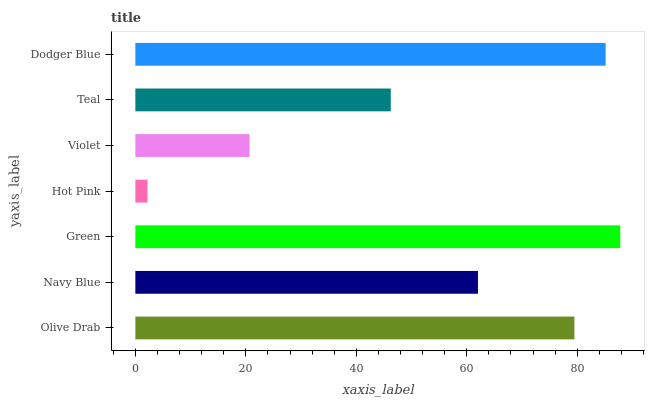Is Hot Pink the minimum?
Answer yes or no. Yes. Is Green the maximum?
Answer yes or no. Yes. Is Navy Blue the minimum?
Answer yes or no. No. Is Navy Blue the maximum?
Answer yes or no. No. Is Olive Drab greater than Navy Blue?
Answer yes or no. Yes. Is Navy Blue less than Olive Drab?
Answer yes or no. Yes. Is Navy Blue greater than Olive Drab?
Answer yes or no. No. Is Olive Drab less than Navy Blue?
Answer yes or no. No. Is Navy Blue the high median?
Answer yes or no. Yes. Is Navy Blue the low median?
Answer yes or no. Yes. Is Violet the high median?
Answer yes or no. No. Is Green the low median?
Answer yes or no. No. 